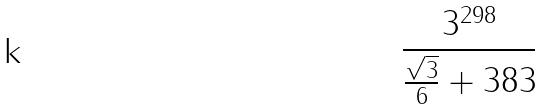Convert formula to latex. <formula><loc_0><loc_0><loc_500><loc_500>\frac { 3 ^ { 2 9 8 } } { \frac { \sqrt { 3 } } { 6 } + 3 8 3 }</formula> 